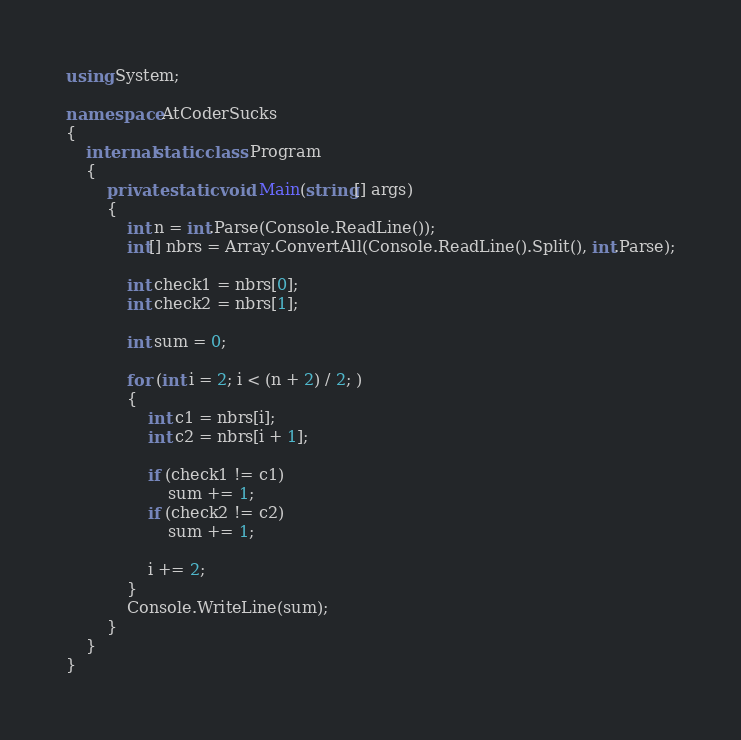<code> <loc_0><loc_0><loc_500><loc_500><_C#_>using System;

namespace AtCoderSucks
{
    internal static class Program
    {
        private static void Main(string[] args)
        {
            int n = int.Parse(Console.ReadLine());
            int[] nbrs = Array.ConvertAll(Console.ReadLine().Split(), int.Parse);

            int check1 = nbrs[0];
            int check2 = nbrs[1];

            int sum = 0;

            for (int i = 2; i < (n + 2) / 2; )
            {
                int c1 = nbrs[i];
                int c2 = nbrs[i + 1];

                if (check1 != c1)
                    sum += 1;
                if (check2 != c2)
                    sum += 1;

                i += 2;
            }
            Console.WriteLine(sum);
        }
    }
}
</code> 